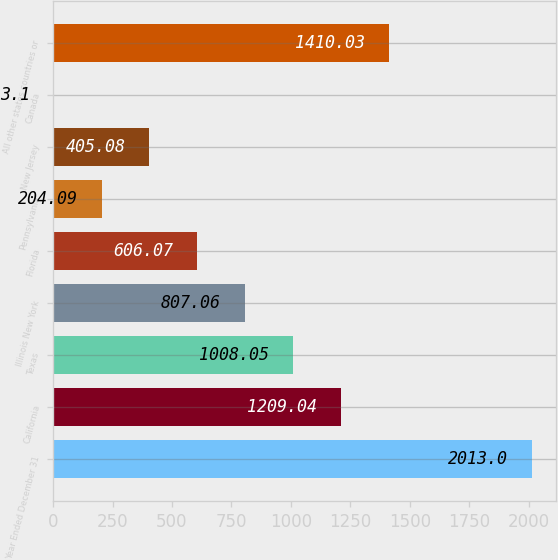Convert chart to OTSL. <chart><loc_0><loc_0><loc_500><loc_500><bar_chart><fcel>Year Ended December 31<fcel>California<fcel>Texas<fcel>Illinois New York<fcel>Florida<fcel>Pennsylvania<fcel>New Jersey<fcel>Canada<fcel>All other states countries or<nl><fcel>2013<fcel>1209.04<fcel>1008.05<fcel>807.06<fcel>606.07<fcel>204.09<fcel>405.08<fcel>3.1<fcel>1410.03<nl></chart> 